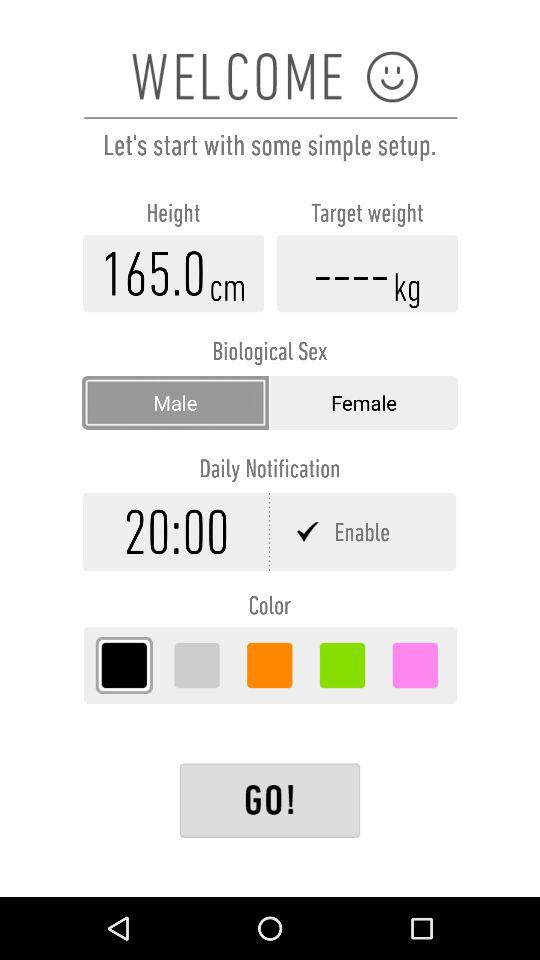What is the unit of target weight? The unit is kg. 